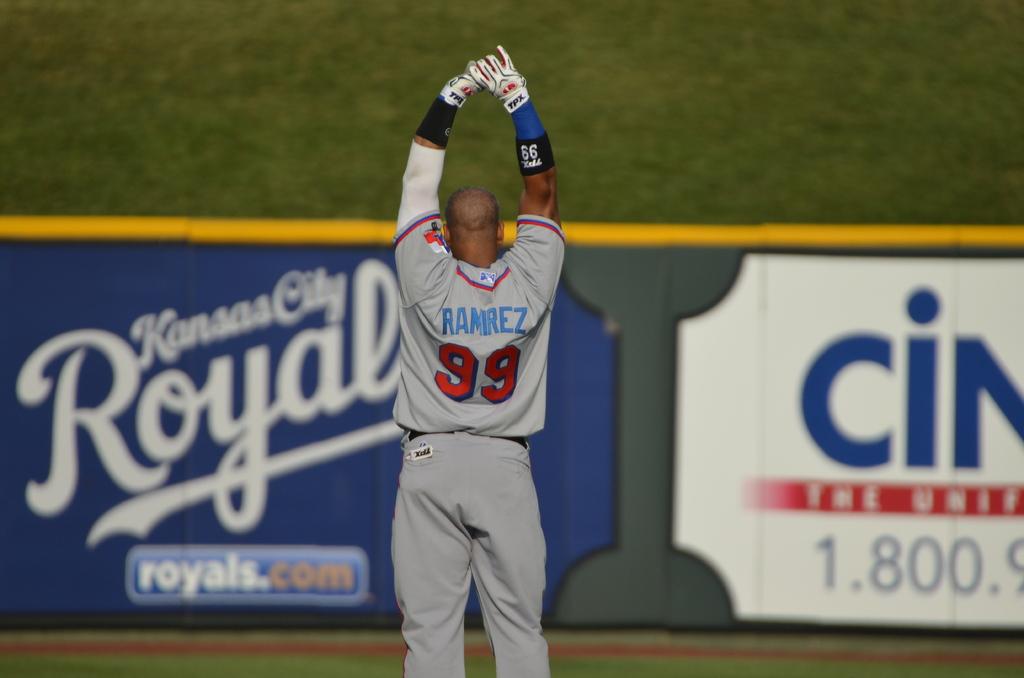What is this players number?
Provide a succinct answer. 99. 